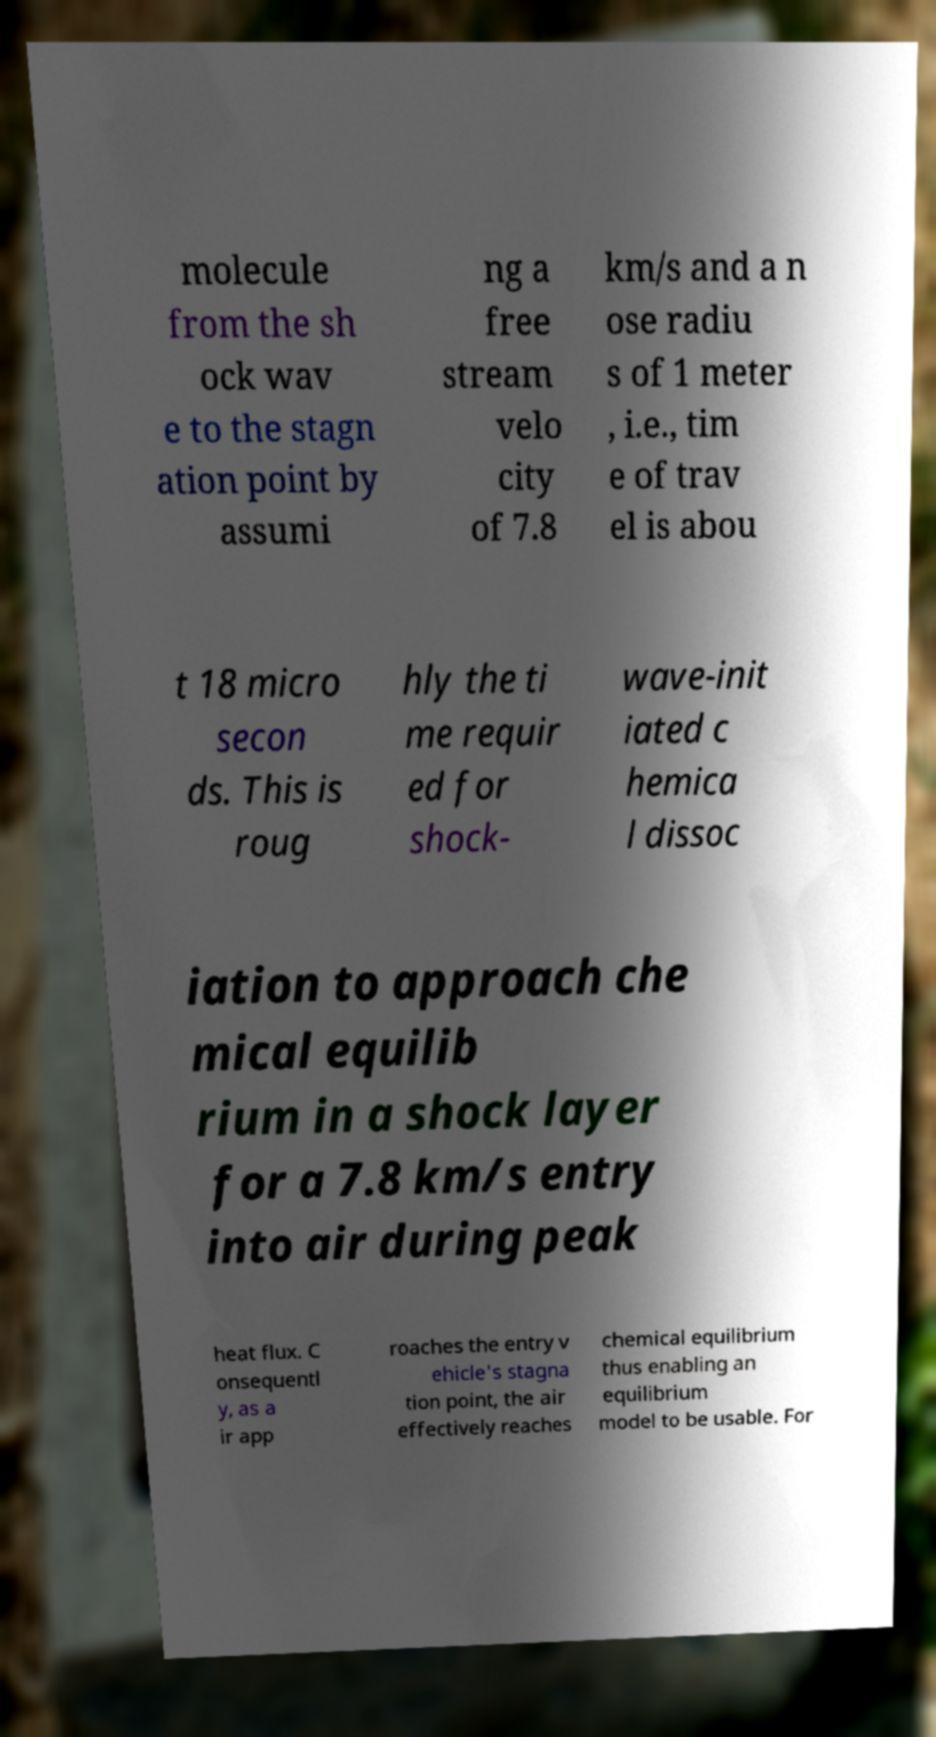Can you read and provide the text displayed in the image?This photo seems to have some interesting text. Can you extract and type it out for me? molecule from the sh ock wav e to the stagn ation point by assumi ng a free stream velo city of 7.8 km/s and a n ose radiu s of 1 meter , i.e., tim e of trav el is abou t 18 micro secon ds. This is roug hly the ti me requir ed for shock- wave-init iated c hemica l dissoc iation to approach che mical equilib rium in a shock layer for a 7.8 km/s entry into air during peak heat flux. C onsequentl y, as a ir app roaches the entry v ehicle's stagna tion point, the air effectively reaches chemical equilibrium thus enabling an equilibrium model to be usable. For 